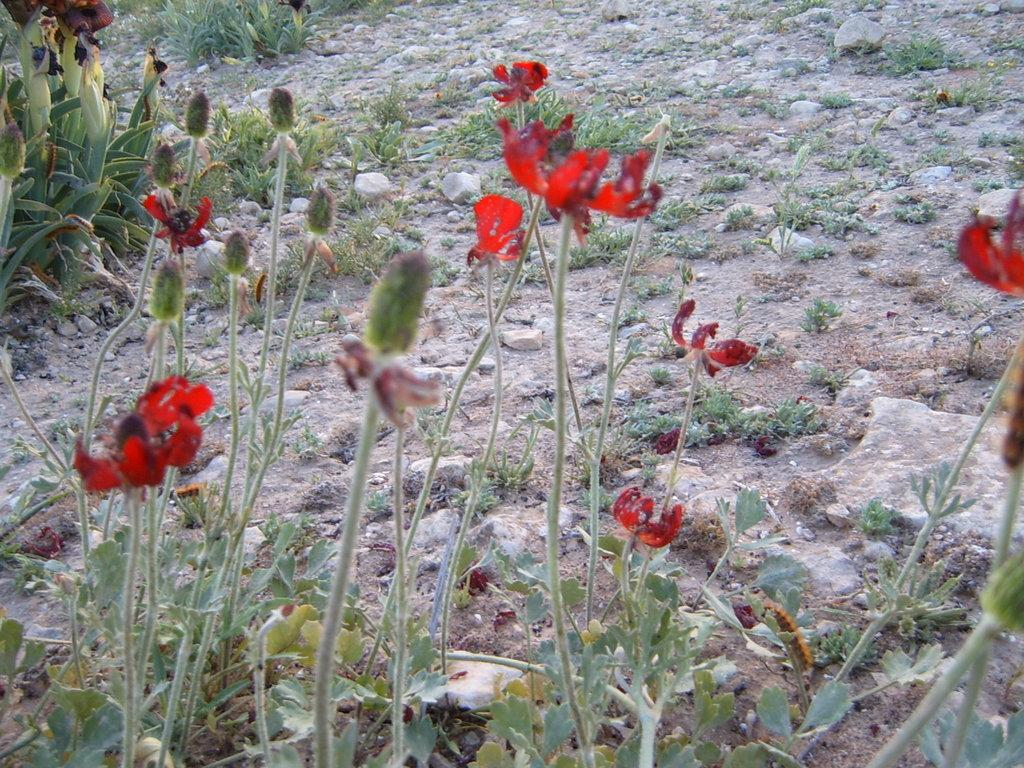What type of vegetation can be seen in the image? There are flowers on a plant in the image. What type of terrain is visible in the image? There is land visible in the image. What type of plastic object can be seen in the image? There is no plastic object present in the image. What activity is taking place in the image? The image does not depict any specific activity; it simply shows flowers on a plant and land. 